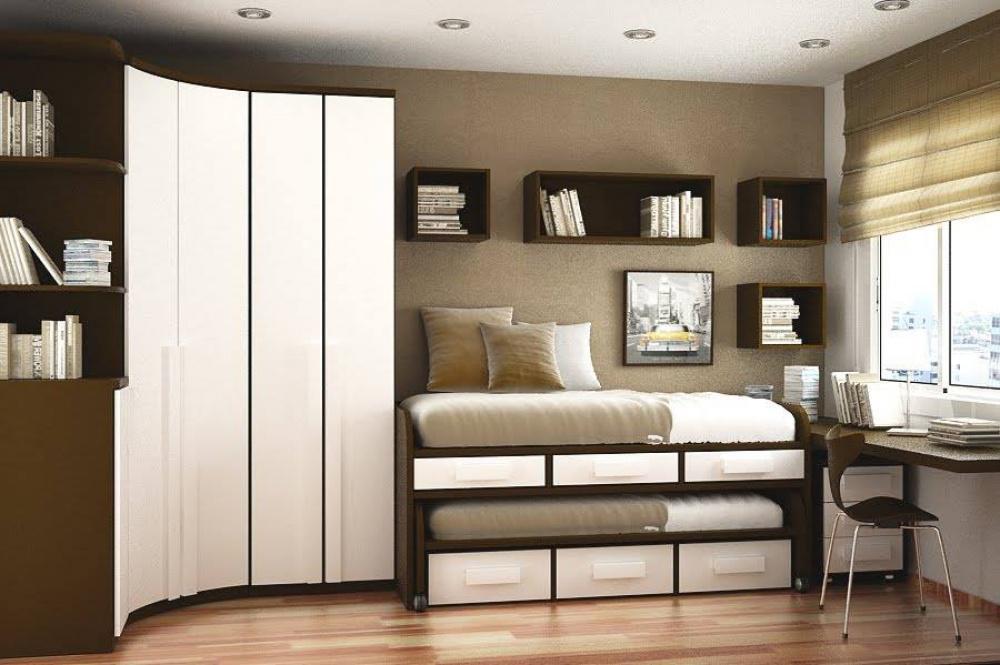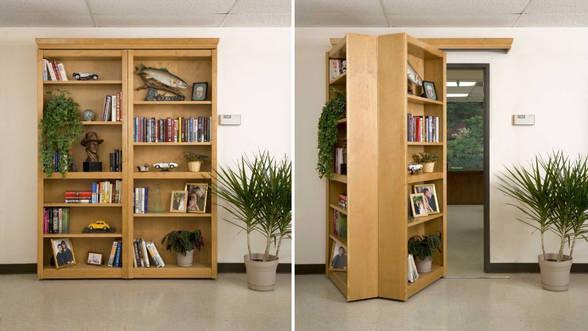The first image is the image on the left, the second image is the image on the right. Given the left and right images, does the statement "THere are at least three floating bookshelves next to a twin bed." hold true? Answer yes or no. Yes. The first image is the image on the left, the second image is the image on the right. For the images displayed, is the sentence "The left image shows at least one chair in front of a pair of windows with a blue glow, and shelving along one wall." factually correct? Answer yes or no. No. 